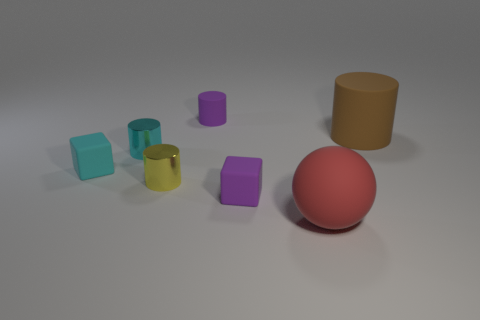Subtract 1 cylinders. How many cylinders are left? 3 Add 3 small cyan shiny cylinders. How many objects exist? 10 Subtract all cubes. How many objects are left? 5 Add 1 brown rubber things. How many brown rubber things exist? 2 Subtract 0 cyan spheres. How many objects are left? 7 Subtract all cyan cylinders. Subtract all purple rubber blocks. How many objects are left? 5 Add 3 red rubber spheres. How many red rubber spheres are left? 4 